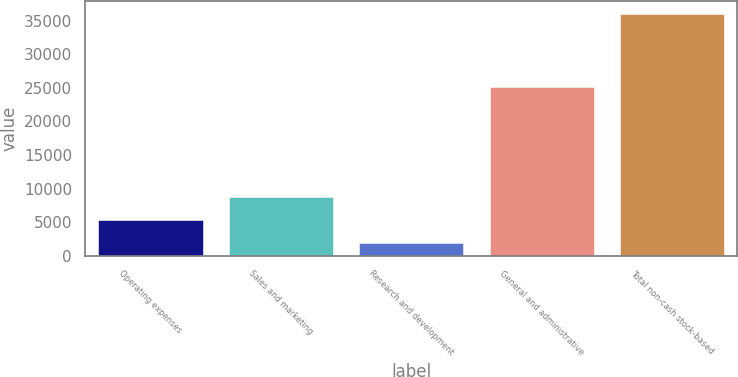Convert chart to OTSL. <chart><loc_0><loc_0><loc_500><loc_500><bar_chart><fcel>Operating expenses<fcel>Sales and marketing<fcel>Research and development<fcel>General and administrative<fcel>Total non-cash stock-based<nl><fcel>5325.5<fcel>8739<fcel>1912<fcel>25162<fcel>36047<nl></chart> 